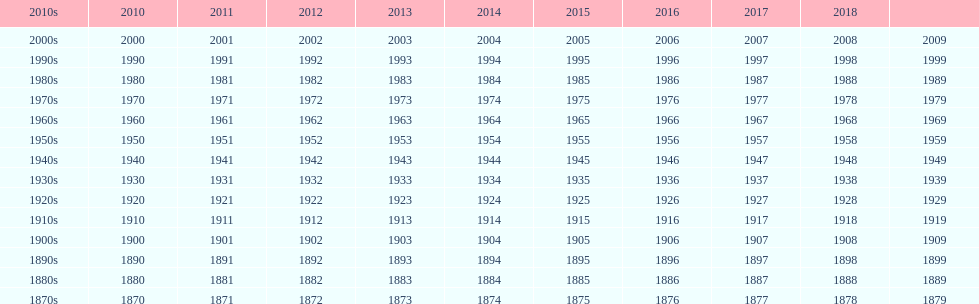Which ten-year period has a smaller number of years in its series than the rest? 2010s. Help me parse the entirety of this table. {'header': ['2010s', '2010', '2011', '2012', '2013', '2014', '2015', '2016', '2017', '2018', ''], 'rows': [['2000s', '2000', '2001', '2002', '2003', '2004', '2005', '2006', '2007', '2008', '2009'], ['1990s', '1990', '1991', '1992', '1993', '1994', '1995', '1996', '1997', '1998', '1999'], ['1980s', '1980', '1981', '1982', '1983', '1984', '1985', '1986', '1987', '1988', '1989'], ['1970s', '1970', '1971', '1972', '1973', '1974', '1975', '1976', '1977', '1978', '1979'], ['1960s', '1960', '1961', '1962', '1963', '1964', '1965', '1966', '1967', '1968', '1969'], ['1950s', '1950', '1951', '1952', '1953', '1954', '1955', '1956', '1957', '1958', '1959'], ['1940s', '1940', '1941', '1942', '1943', '1944', '1945', '1946', '1947', '1948', '1949'], ['1930s', '1930', '1931', '1932', '1933', '1934', '1935', '1936', '1937', '1938', '1939'], ['1920s', '1920', '1921', '1922', '1923', '1924', '1925', '1926', '1927', '1928', '1929'], ['1910s', '1910', '1911', '1912', '1913', '1914', '1915', '1916', '1917', '1918', '1919'], ['1900s', '1900', '1901', '1902', '1903', '1904', '1905', '1906', '1907', '1908', '1909'], ['1890s', '1890', '1891', '1892', '1893', '1894', '1895', '1896', '1897', '1898', '1899'], ['1880s', '1880', '1881', '1882', '1883', '1884', '1885', '1886', '1887', '1888', '1889'], ['1870s', '1870', '1871', '1872', '1873', '1874', '1875', '1876', '1877', '1878', '1879']]} 